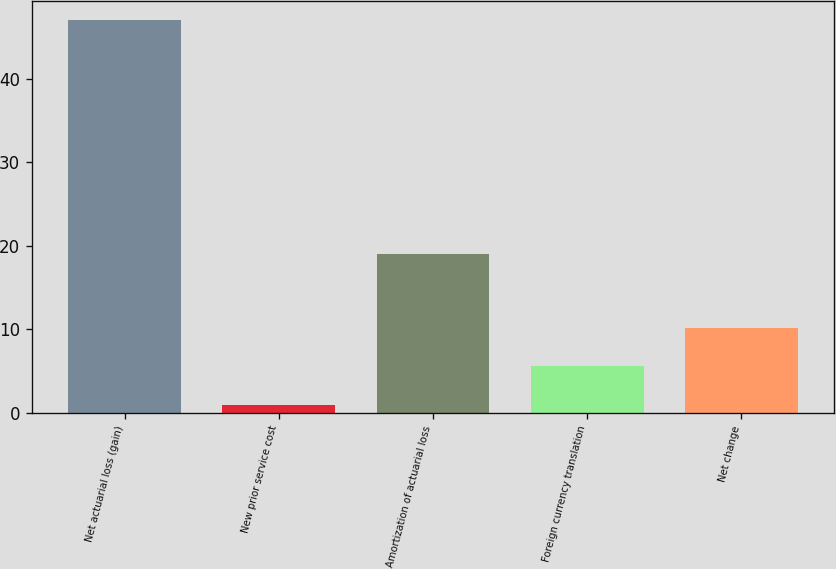Convert chart to OTSL. <chart><loc_0><loc_0><loc_500><loc_500><bar_chart><fcel>Net actuarial loss (gain)<fcel>New prior service cost<fcel>Amortization of actuarial loss<fcel>Foreign currency translation<fcel>Net change<nl><fcel>47<fcel>1<fcel>19<fcel>5.6<fcel>10.2<nl></chart> 